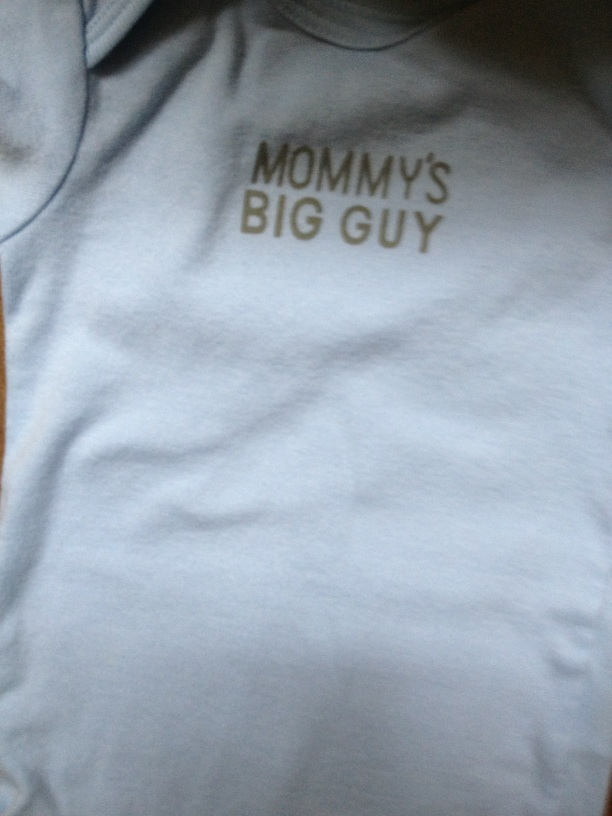What color is the baby's shirt? The baby's shirt is light blue. 